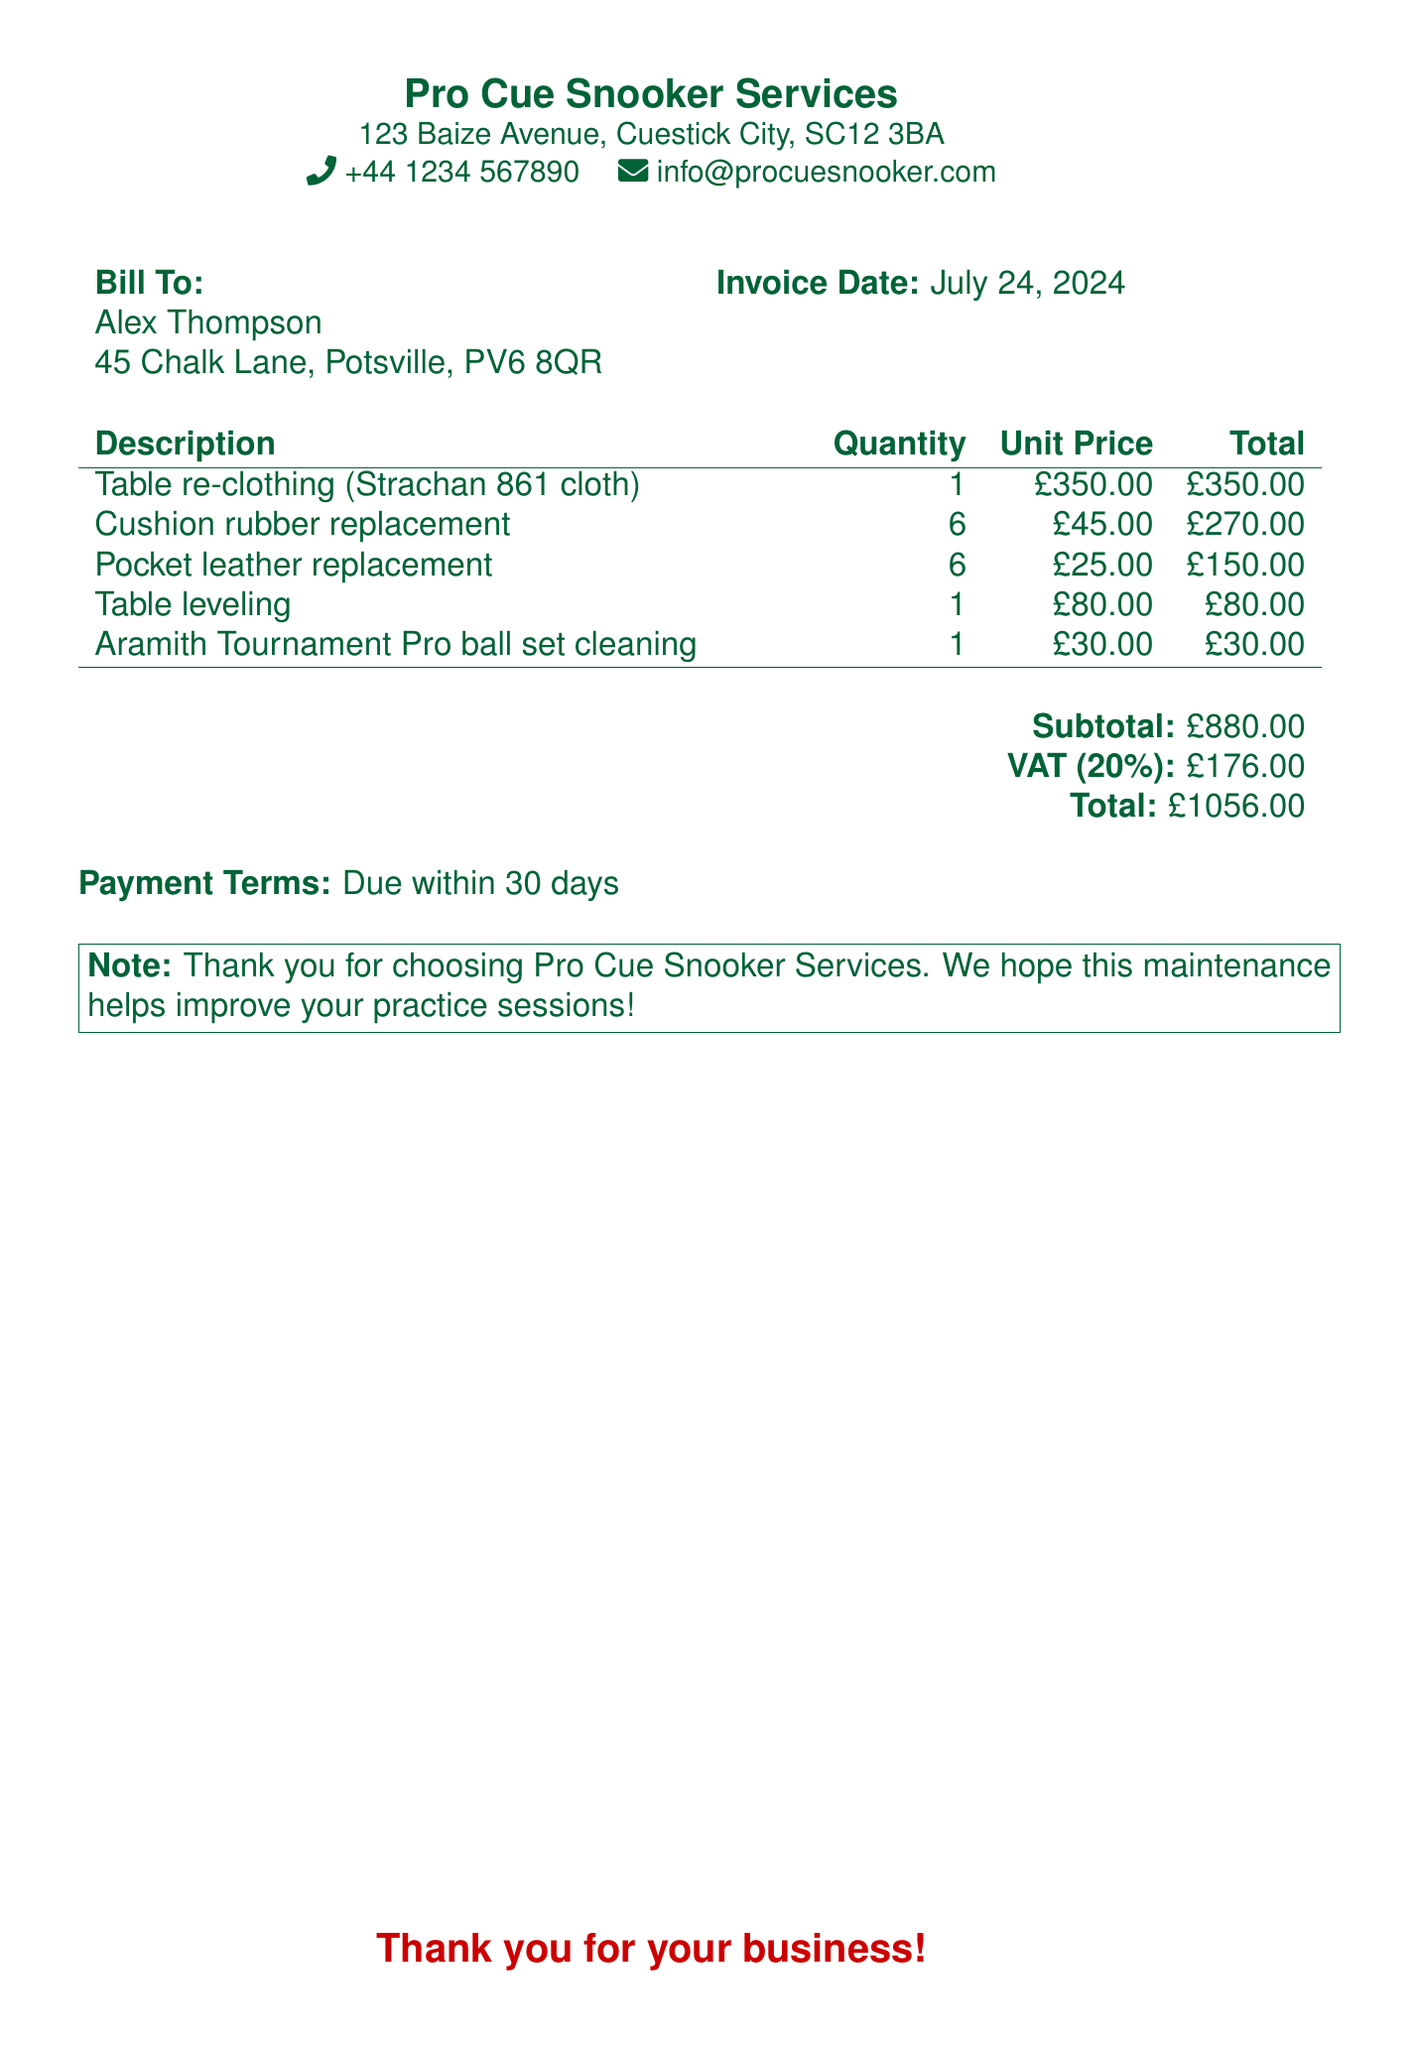What is the name of the service provider? The name of the service provider is listed at the top of the bill.
Answer: Pro Cue Snooker Services Who is the bill addressed to? The bill is addressed to the individual shown in the "Bill To" section.
Answer: Alex Thompson What is the invoice date? The invoice date is mentioned at the top and is the same for every instance of this bill due to the use of \today.
Answer: today What is the total amount due? The total amount due is clearly stated at the bottom of the bill.
Answer: £1056.00 How many cushion rubber replacements were included? The quantity of cushion rubber replacements is mentioned in the table detailing the services.
Answer: 6 What is the unit price for table re-clothing? The unit price for table re-clothing can be found in the service description table.
Answer: £350.00 What is the VAT percentage applied? The VAT percentage is calculated based on the subtotal and is stated in the document.
Answer: 20% What is listed as the payment terms? The payment terms are stated near the bottom of the bill, defining the timeframe for payment.
Answer: Due within 30 days What is the subtotal for all services before VAT? The subtotal is explicitly detailed in the bill right before the VAT calculation.
Answer: £880.00 What type of cloth was used for the table re-clothing? The type of cloth used can be found in the service description under table re-clothing.
Answer: Strachan 861 cloth 